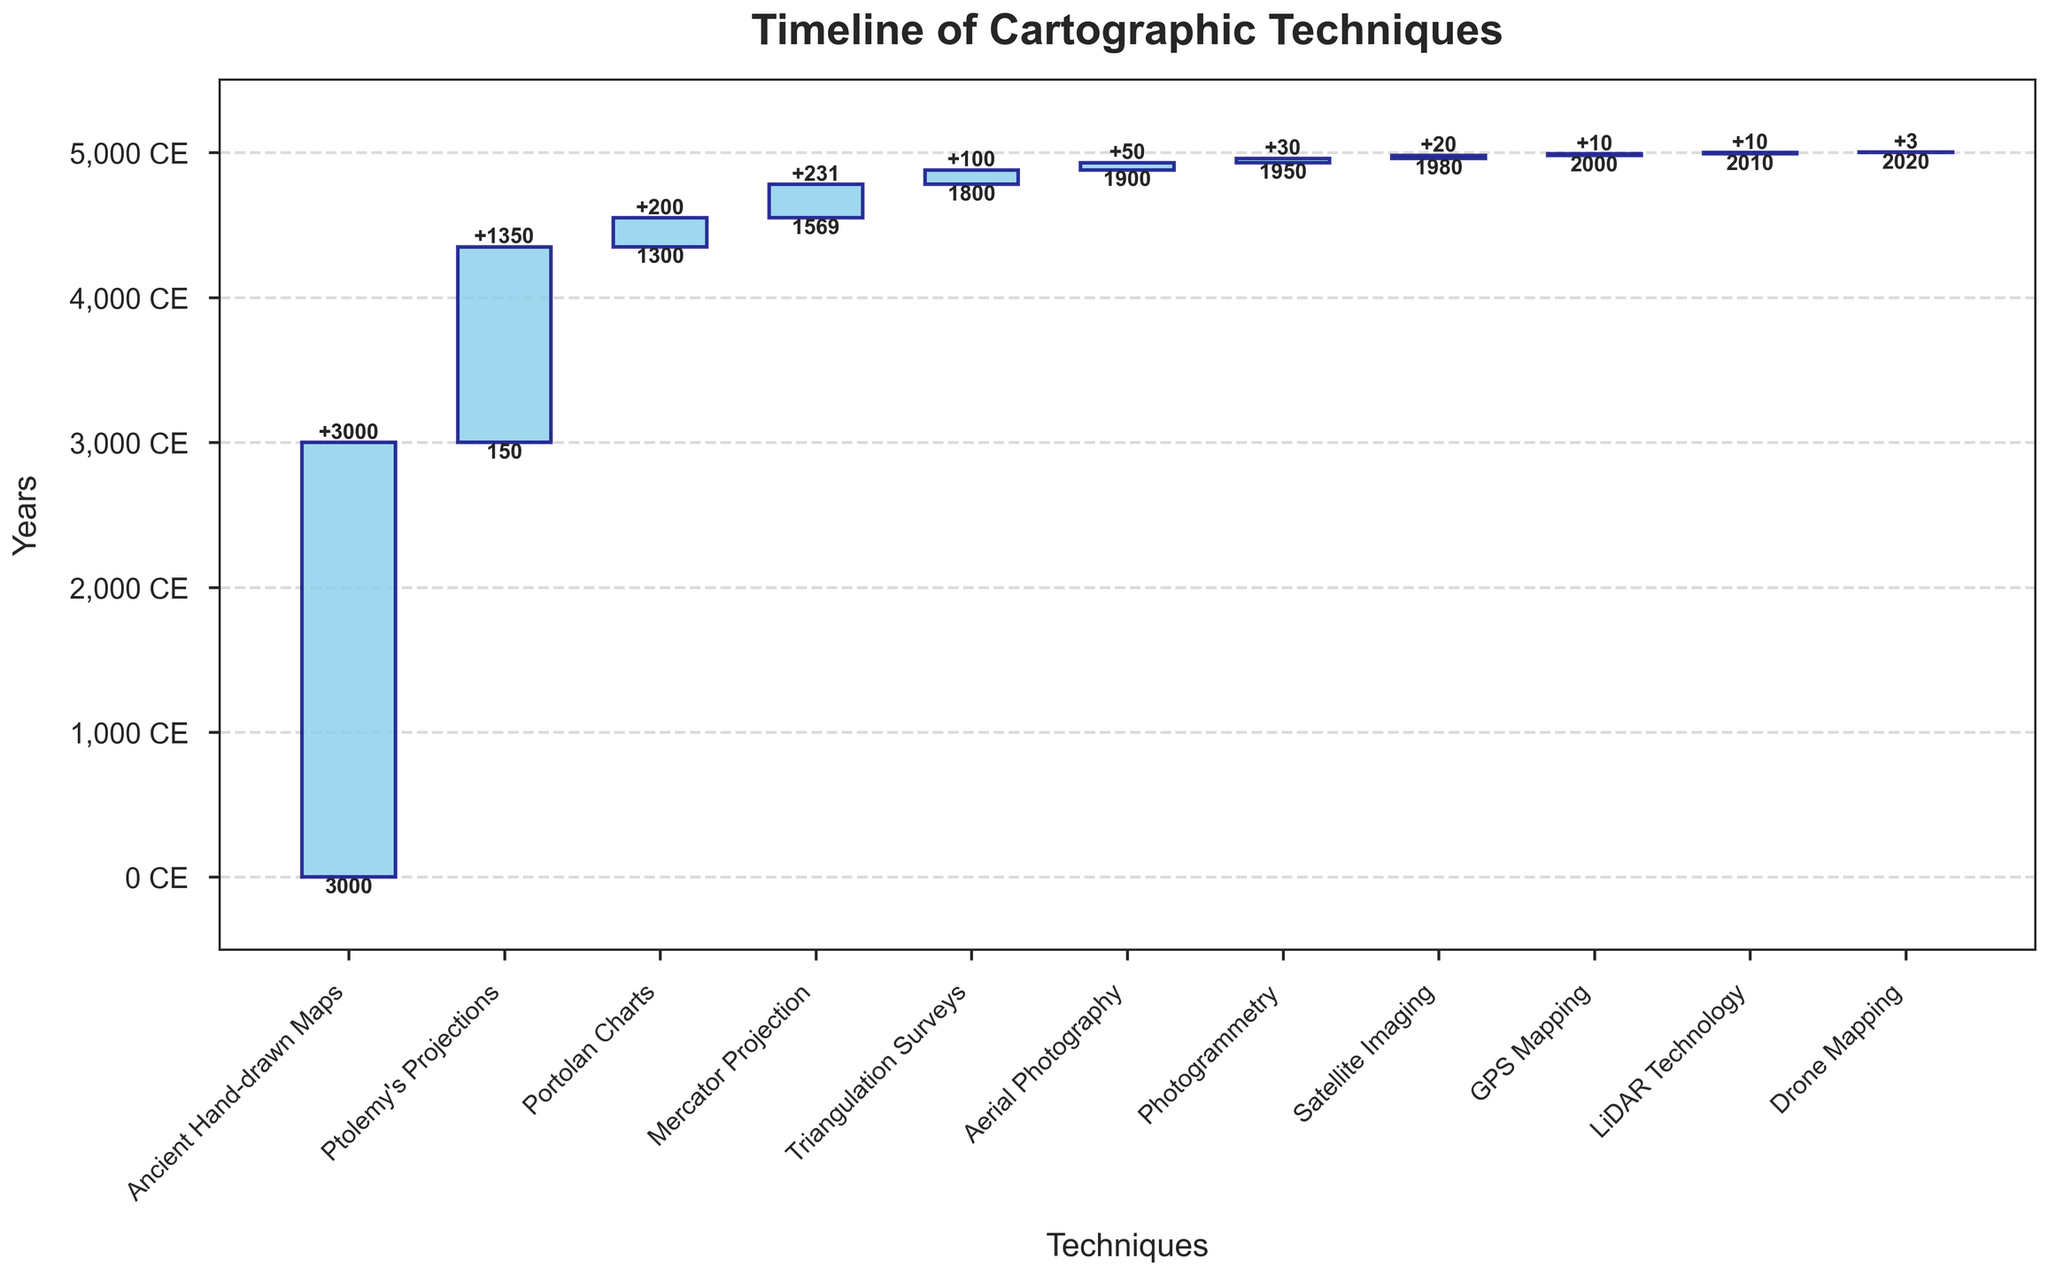What is the title of the figure? The title is typically displayed at the top of the chart. It is clearly written and usually provides a summary of what the figure is about.
Answer: Timeline of Cartographic Techniques What is the range of years covered by the chart? To determine the range, look at the year labels on the y-axis from the earliest to the latest point, starting from "Ancient Hand-drawn Maps" until "Drone Mapping".
Answer: -3000 BCE to 2020 What cartographic technique took the longest time span to reach the next technique? To identify this, look at the duration of each technique as shown by the bar lengths. The longest duration will be the highest bar.
Answer: Ancient Hand-drawn Maps Which technique followed Ptolemy's Projections according to the timeline? By following the sequence in the chart from left to right, examining the labels of each technique, you can determine the next one after Ptolemy's Projections.
Answer: Portolan Charts How many techniques were developed after 1800 CE according to the chart? Count the techniques starting from the year 1800 onwards in the chart, based on the year labels.
Answer: 6 What is the duration by which Mercator Projection predates Triangulation Surveys? To find the difference in years between when Mercator Projection and Triangulation Surveys started, look at their respective years and calculate the difference.
Answer: 231 years What is the sum of the durations of Satellite Imaging and GPS Mapping techniques? Add the duration years of Satellite Imaging and GPS Mapping as shown on the chart.
Answer: 30 years How does the duration of Aerial Photography compare to Photogrammetry? Compare the lengths of the bars representing Aerial Photography and Photogrammetry to see which took longer in years.
Answer: Aerial Photography lasted longer Which technique shortest-path followed Triangulation Surveys? Identify which technique comes immediately after Triangulation Surveys in the chart.
Answer: Aerial Photography Is Drone Mapping the most recent technique on the chart? Verify if Drone Mapping is the last (most recent) technique listed based on the timeline progression in the chart.
Answer: Yes 